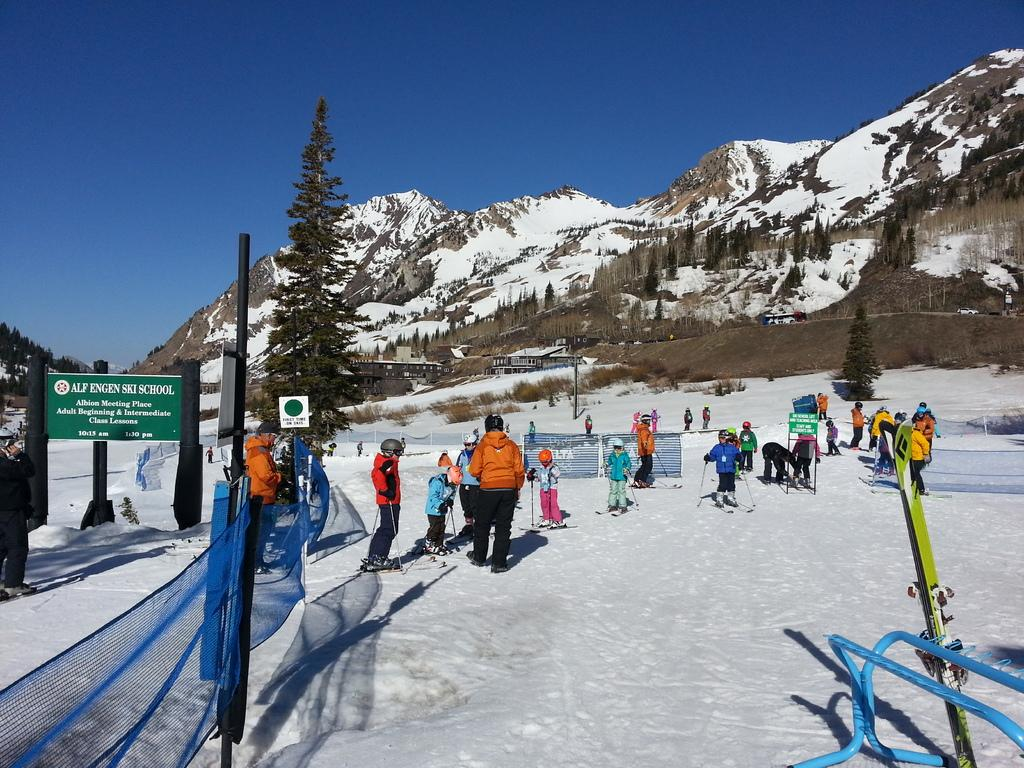What are the people in the image doing? The people in the image are skating. What surface are they skating on? They are skating on snow. What can be seen in the background of the image? There are mountains and trees in the background of the image. What is the condition of the mountains and trees? The mountains and trees are covered with snow. What is the color of the sky in the image? The sky is blue in color. What type of army is present in the image? There is no army present in the image; it features a group of people skating on snow with mountains and trees in the background. What force is being exerted by the people's eyes in the image? There is no mention of any force being exerted by the people's eyes in the image. 